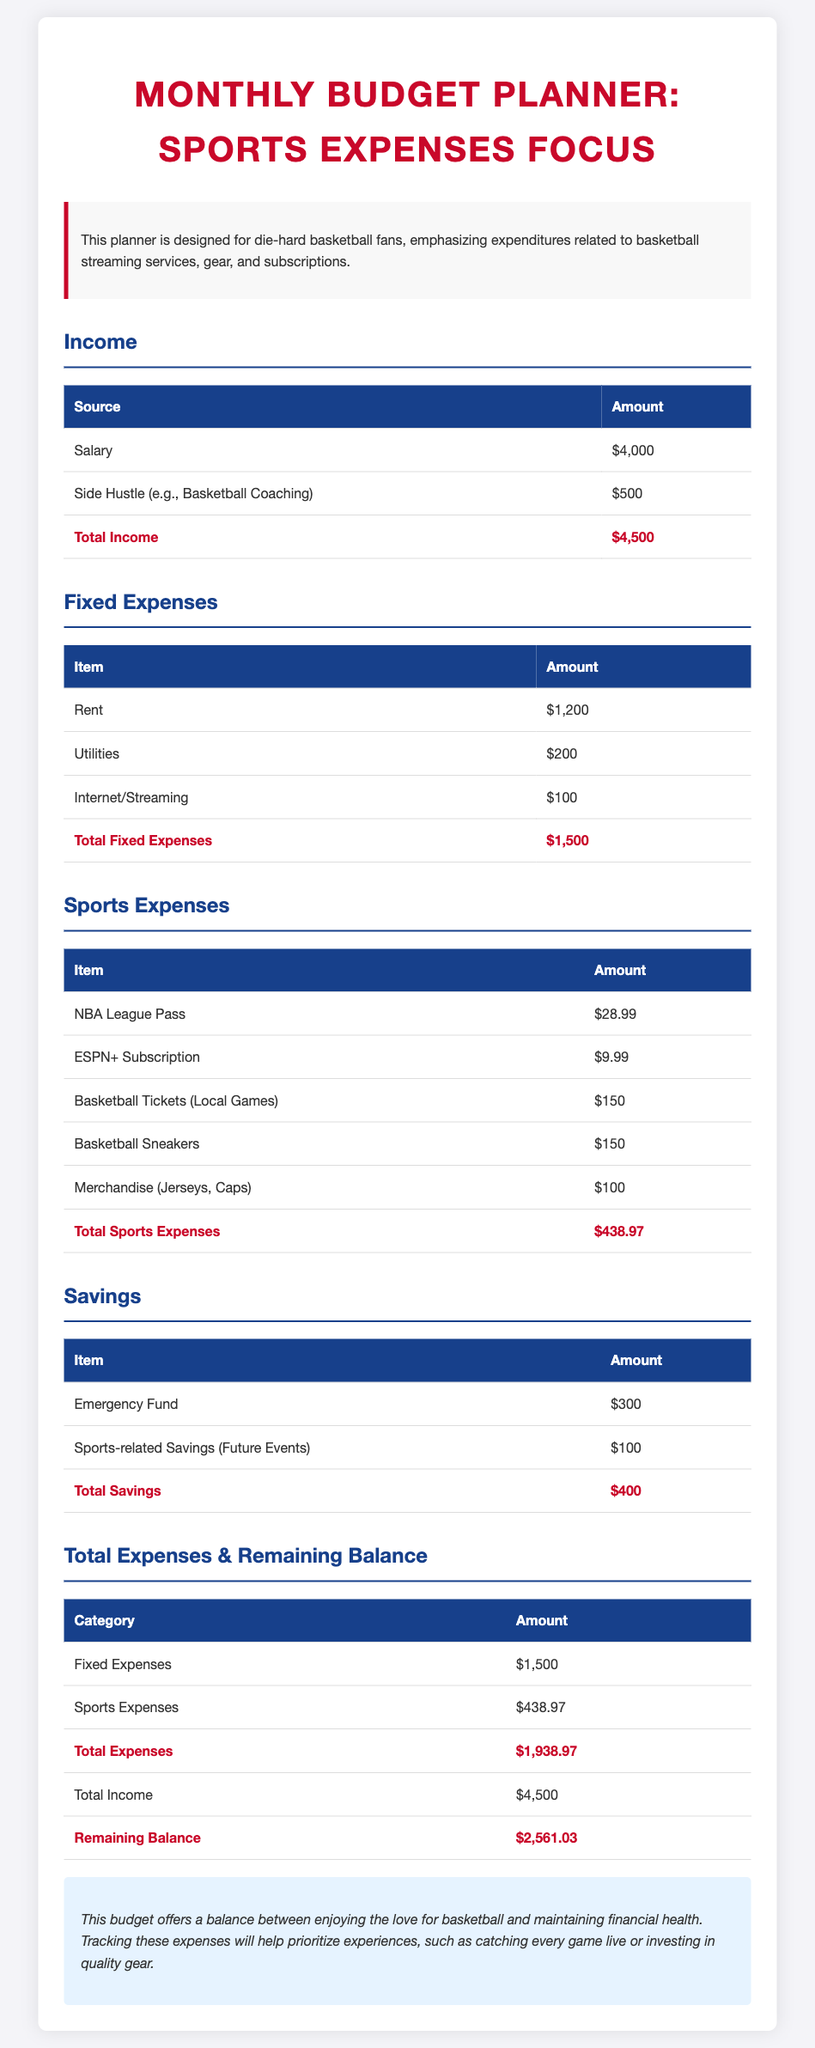What is the total income? The total income is presented in the document as the sum of salary and side hustle, which is $4000 + $500.
Answer: $4500 What are the fixed expenses? The total fixed expenses are calculated by summing rent, utilities, and internet/streaming, which amounts to $1200 + $200 + $100.
Answer: $1500 What is the amount for basketball tickets? The document specifies the expense for basketball tickets.
Answer: $150 What is the total sports expenses? The total sports expenses represent the sum of all listed sports-related expenditures, which are detailed in the table.
Answer: $438.97 What percentage of total income is allocated to sports expenses? The percentage is calculated by dividing total sports expenses by total income and multiplying by 100. The values are $438.97 divided by $4500.
Answer: 9.76% What is the remaining balance? The remaining balance is calculated by subtracting total expenses from total income, which is $4500 - $1938.97.
Answer: $2561.03 What type of budget is this document aimed at? The budget is created specifically for basketball fans focusing on sports-related expenses.
Answer: Sports Expenses Focus How much is allocated to sports-related savings? The amount set aside for sports-related savings is clearly specified in the savings section of the document.
Answer: $100 What is the total amount in the emergency fund? This is stated directly in the savings section of the document as the amount designated for emergencies.
Answer: $300 